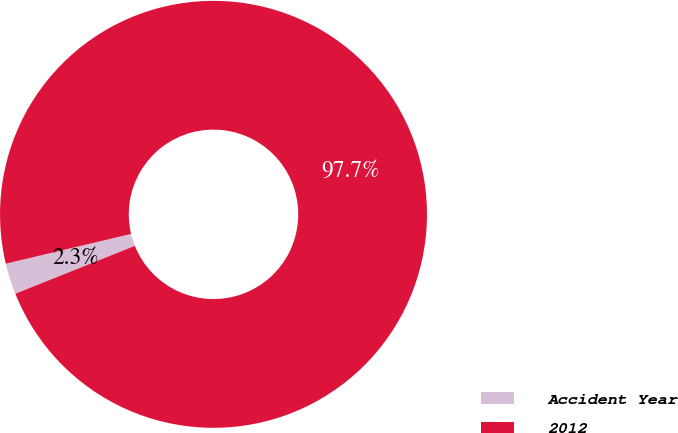Convert chart. <chart><loc_0><loc_0><loc_500><loc_500><pie_chart><fcel>Accident Year<fcel>2012<nl><fcel>2.35%<fcel>97.65%<nl></chart> 